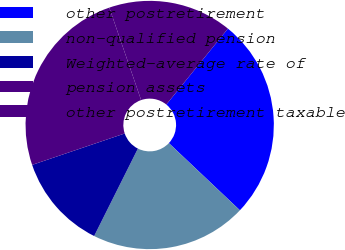Convert chart to OTSL. <chart><loc_0><loc_0><loc_500><loc_500><pie_chart><fcel>other postretirement<fcel>non-qualified pension<fcel>Weighted-average rate of<fcel>pension assets<fcel>other postretirement taxable<nl><fcel>26.2%<fcel>20.33%<fcel>12.41%<fcel>24.93%<fcel>16.13%<nl></chart> 